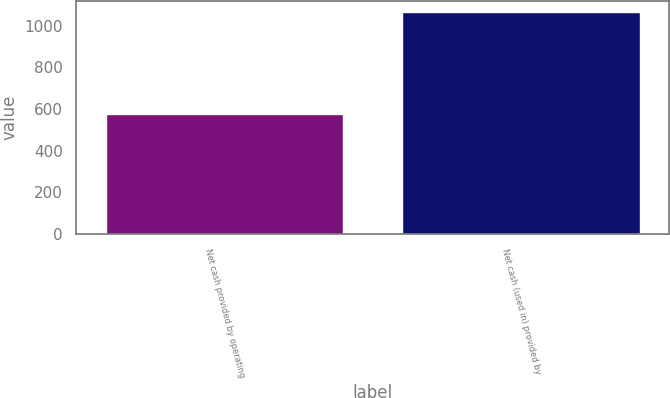Convert chart to OTSL. <chart><loc_0><loc_0><loc_500><loc_500><bar_chart><fcel>Net cash provided by operating<fcel>Net cash (used in) provided by<nl><fcel>577.5<fcel>1064.2<nl></chart> 